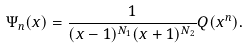Convert formula to latex. <formula><loc_0><loc_0><loc_500><loc_500>\Psi _ { n } ( x ) = \frac { 1 } { ( x - 1 ) ^ { N _ { 1 } } ( x + 1 ) ^ { N _ { 2 } } } Q ( x ^ { n } ) .</formula> 